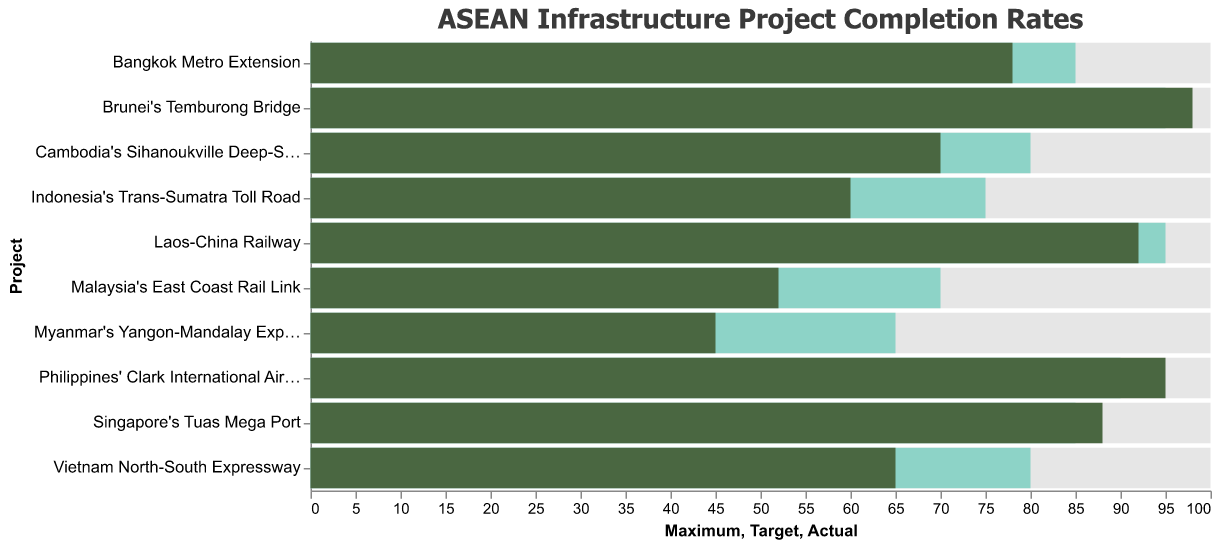How many infrastructure projects met or exceeded their target completion rate? By looking at the bars colored in greenish shades that indicate actual completion rates, compare them to the bars below that indicate target completion rates. There are 4 such projects: 'Philippines' Clark International Airport Expansion', 'Singapore's Tuas Mega Port', 'Laos-China Railway', and 'Brunei's Temburong Bridge'.
Answer: 4 Which project has the largest difference between its actual completion rate and the target completion rate? To find the largest difference, calculate the absolute differences between the actual and target completion rates for all projects. The largest difference is for 'Myanmar's Yangon-Mandalay Expressway' with a difference of 20%.
Answer: Myanmar's Yangon-Mandalay Expressway What is the average actual completion rate of all projects? Add up all the actual completion rates (78 + 65 + 60 + 95 + 52 + 88 + 92 + 45 + 70 + 98) and divide by the number of projects (10). The total is 743, so the average is 743 / 10 = 74.3%.
Answer: 74.3% Which country has the highest actual completion rate for its project? Look for the highest value in the actual completion rate bars (the darkest bars). The highest value is 98%, which is for Brunei's Temburong Bridge.
Answer: Brunei How many projects have an actual completion rate below 70%? Count the number of projects where the actual completion rate (darkest bars) is less than 70%. There are 4 such projects: 'Vietnam North-South Expressway', 'Indonesia's Trans-Sumatra Toll Road', 'Malaysia's East Coast Rail Link', and 'Myanmar's Yangon-Mandalay Expressway'.
Answer: 4 Which project in Singapore has an actual completion rate, and how does it compare to its target? The project in Singapore is 'Singapore's Tuas Mega Port'. The actual completion rate is 88%, and the target completion rate is 85%. 88% is 3% higher than the target rate.
Answer: Actual: 88%, Target 85% (3% higher) Identify the project with the highest target completion rate and compare it to its actual completion rate. Look for the highest value in the target completion rate bars (medium greenish bars). The highest target completion rate is 95%, which is for the 'Laos-China Railway' and 'Brunei's Temburong Bridge'. The actual completion rate for these projects is 92% and 98%, respectively.
Answer: Laos-China Railway: Actual 92%, Target 95%; Brunei's Temburong Bridge: Actual 98%, Target 95% How much higher is the actual completion rate of 'Philippines' Clark International Airport Expansion' compared to 'Malaysia's East Coast Rail Link'? Subtract the actual completion rate of 'Malaysia's East Coast Rail Link' (52%) from the actual completion rate of 'Philippines' Clark International Airport Expansion' (95%). 95% - 52% = 43%.
Answer: 43% What's the median actual completion rate of the projects? First, sort the actual completion rates in ascending order: (45, 52, 60, 65, 70, 78, 88, 92, 95, 98). The median value is the middle value. Since there are 10 projects, the median is the average of the 5th and 6th values: (70 + 78) / 2 = 74%.
Answer: 74% 